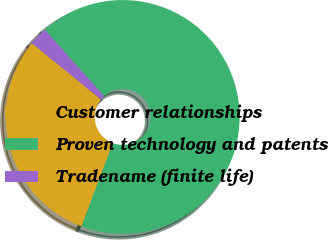<chart> <loc_0><loc_0><loc_500><loc_500><pie_chart><fcel>Customer relationships<fcel>Proven technology and patents<fcel>Tradename (finite life)<nl><fcel>30.13%<fcel>67.32%<fcel>2.55%<nl></chart> 